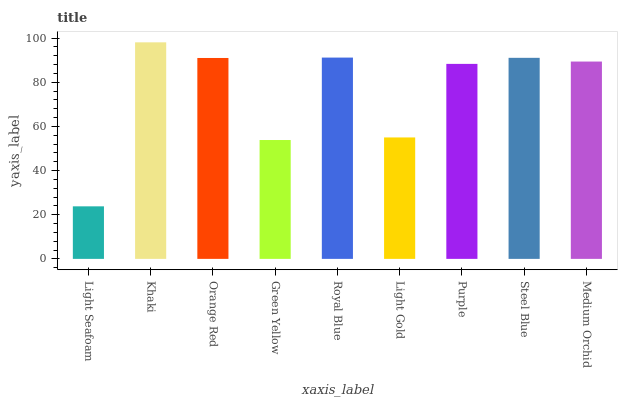Is Orange Red the minimum?
Answer yes or no. No. Is Orange Red the maximum?
Answer yes or no. No. Is Khaki greater than Orange Red?
Answer yes or no. Yes. Is Orange Red less than Khaki?
Answer yes or no. Yes. Is Orange Red greater than Khaki?
Answer yes or no. No. Is Khaki less than Orange Red?
Answer yes or no. No. Is Medium Orchid the high median?
Answer yes or no. Yes. Is Medium Orchid the low median?
Answer yes or no. Yes. Is Orange Red the high median?
Answer yes or no. No. Is Steel Blue the low median?
Answer yes or no. No. 